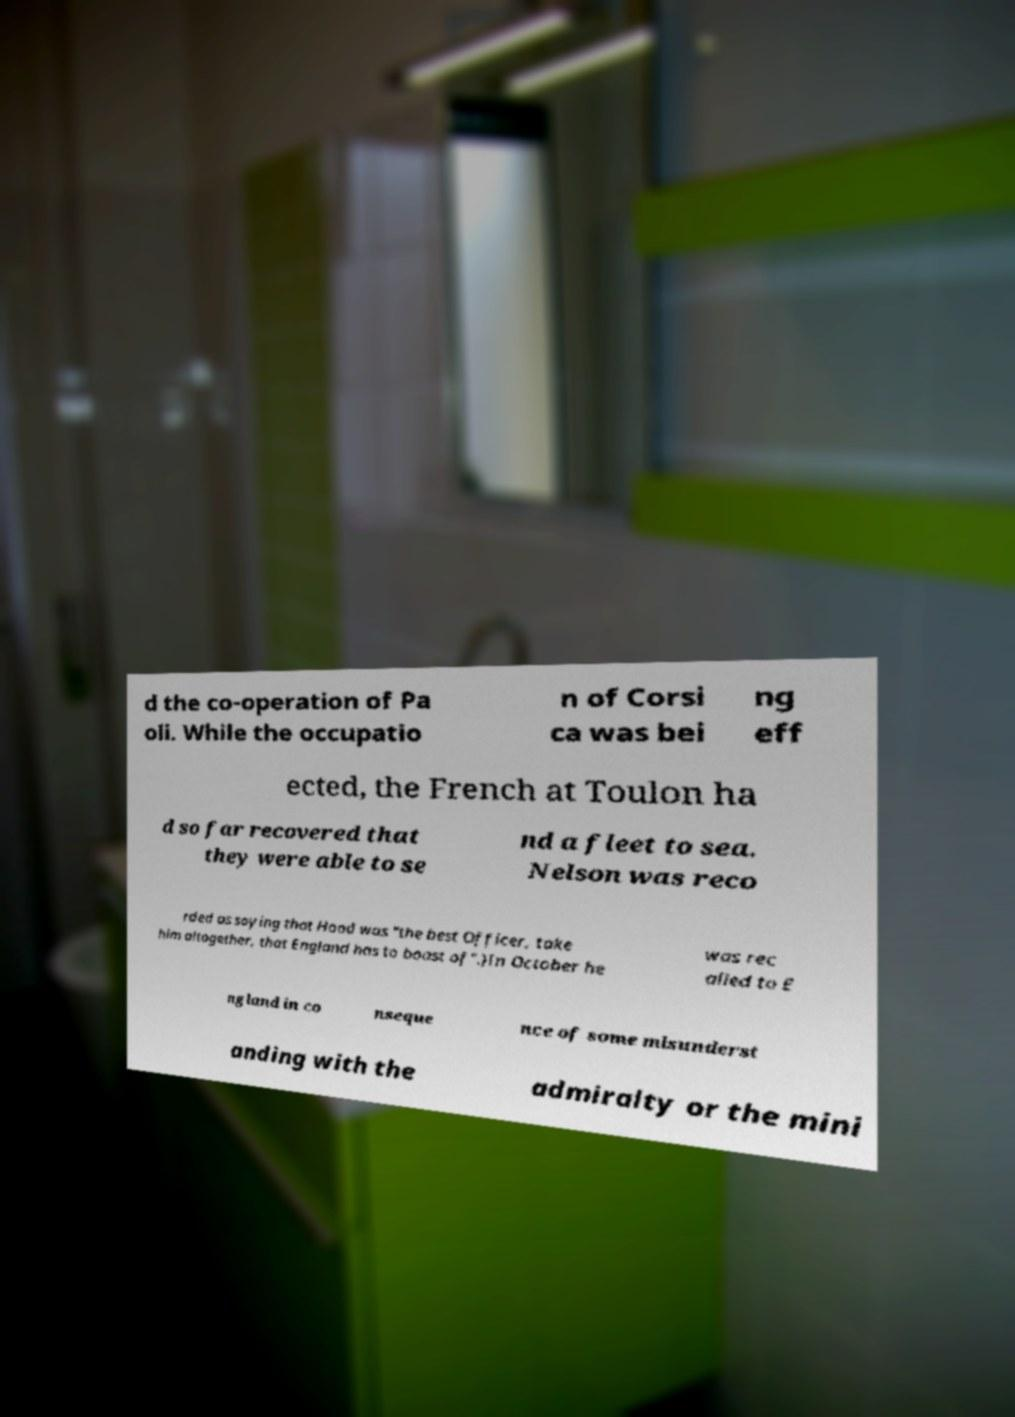Could you extract and type out the text from this image? d the co-operation of Pa oli. While the occupatio n of Corsi ca was bei ng eff ected, the French at Toulon ha d so far recovered that they were able to se nd a fleet to sea. Nelson was reco rded as saying that Hood was "the best Officer, take him altogether, that England has to boast of".)In October he was rec alled to E ngland in co nseque nce of some misunderst anding with the admiralty or the mini 